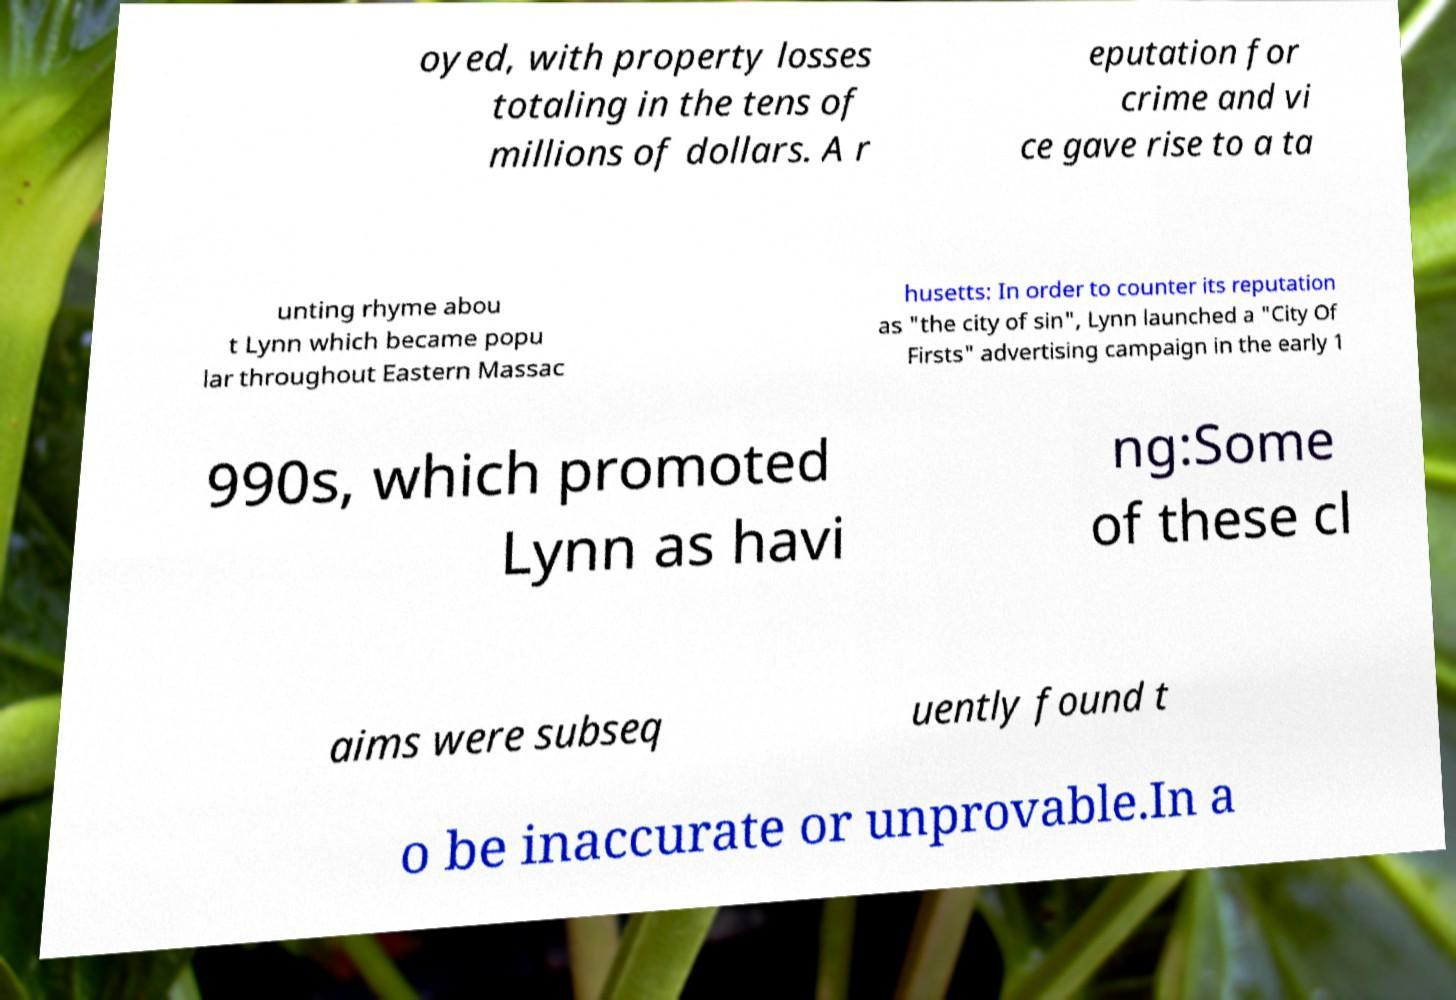Can you read and provide the text displayed in the image?This photo seems to have some interesting text. Can you extract and type it out for me? oyed, with property losses totaling in the tens of millions of dollars. A r eputation for crime and vi ce gave rise to a ta unting rhyme abou t Lynn which became popu lar throughout Eastern Massac husetts: In order to counter its reputation as "the city of sin", Lynn launched a "City Of Firsts" advertising campaign in the early 1 990s, which promoted Lynn as havi ng:Some of these cl aims were subseq uently found t o be inaccurate or unprovable.In a 